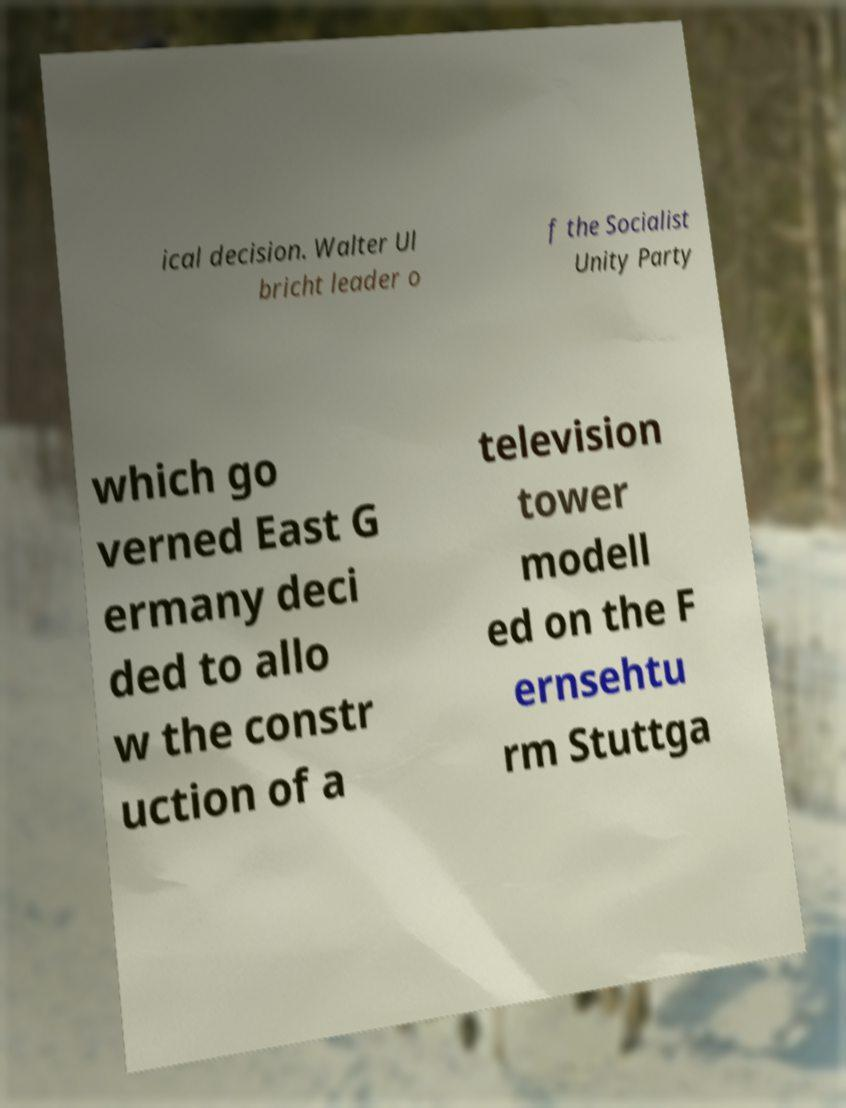Could you extract and type out the text from this image? ical decision. Walter Ul bricht leader o f the Socialist Unity Party which go verned East G ermany deci ded to allo w the constr uction of a television tower modell ed on the F ernsehtu rm Stuttga 